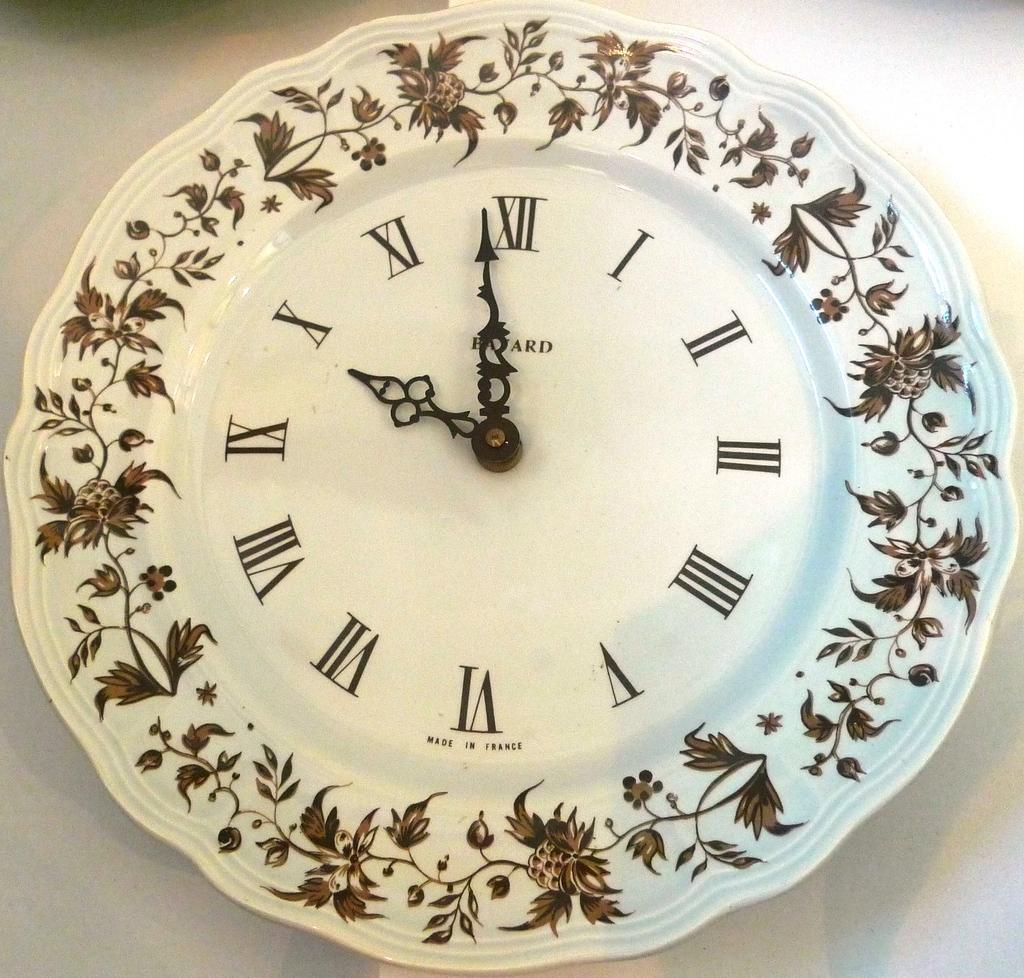<image>
Provide a brief description of the given image. The wall clock looked like a finely decorated china plate displaying the time as 9:58. 